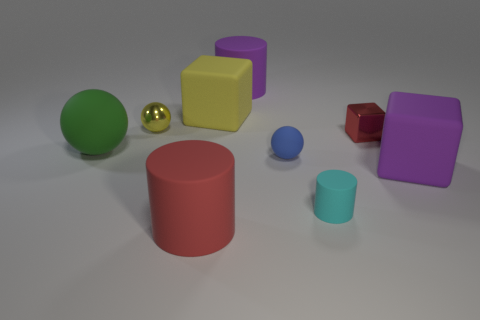Add 1 big purple rubber cylinders. How many objects exist? 10 Subtract all balls. How many objects are left? 6 Subtract 0 green cylinders. How many objects are left? 9 Subtract all big cyan matte spheres. Subtract all big cylinders. How many objects are left? 7 Add 4 large purple cylinders. How many large purple cylinders are left? 5 Add 3 big brown things. How many big brown things exist? 3 